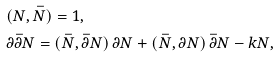Convert formula to latex. <formula><loc_0><loc_0><loc_500><loc_500>& ( { N } , \bar { N } ) = 1 , \\ & \partial \bar { \partial } { N } = ( \bar { N } , \bar { \partial } { N } ) \, \partial { N } + ( \bar { N } , \partial { N } ) \, \bar { \partial } { N } - k { N } ,</formula> 